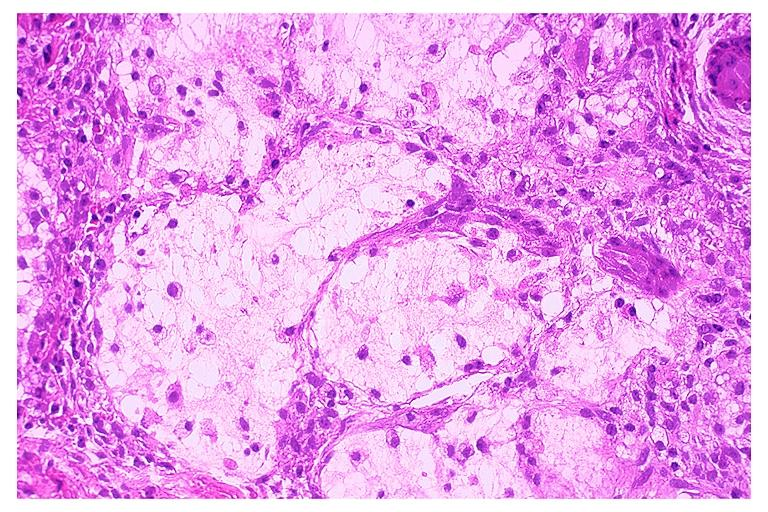where is this?
Answer the question using a single word or phrase. Oral 